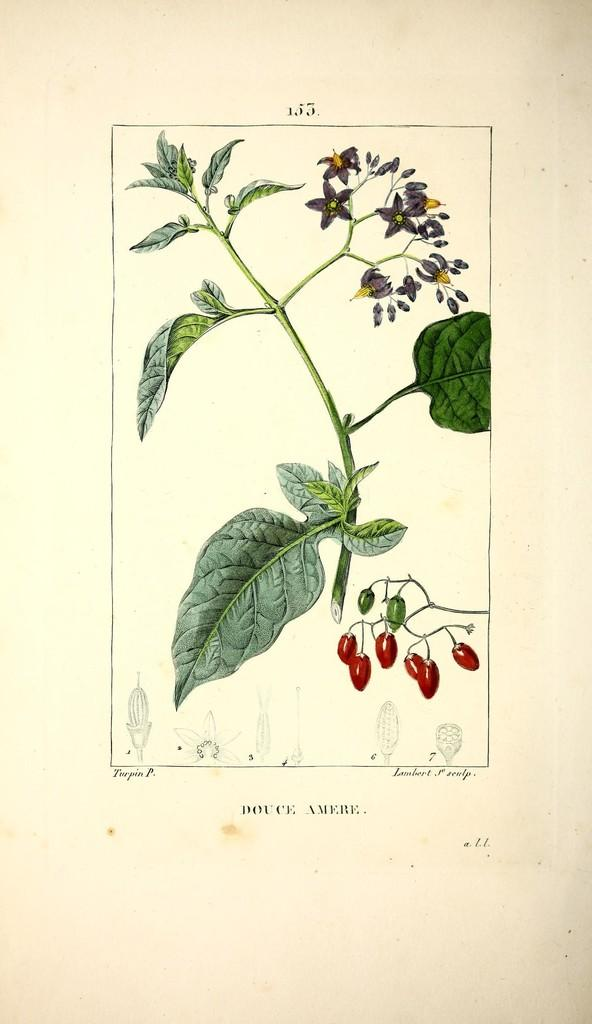What is depicted in the drawing in the image? The image contains a drawing of plants. What specific features of the plants are shown in the drawing? The plants have flowers in the drawing. Are there any other parts of the plants visible in the drawing? Yes, there are buds and parts of the flower at the bottom of the drawing. What type of star can be seen in the drawing of plants? There is no star present in the drawing of plants; it features a depiction of plants with flowers. Can you tell me how many carriages are attached to the plants in the drawing? There are no carriages present in the drawing of plants; it features a depiction of plants with flowers. 